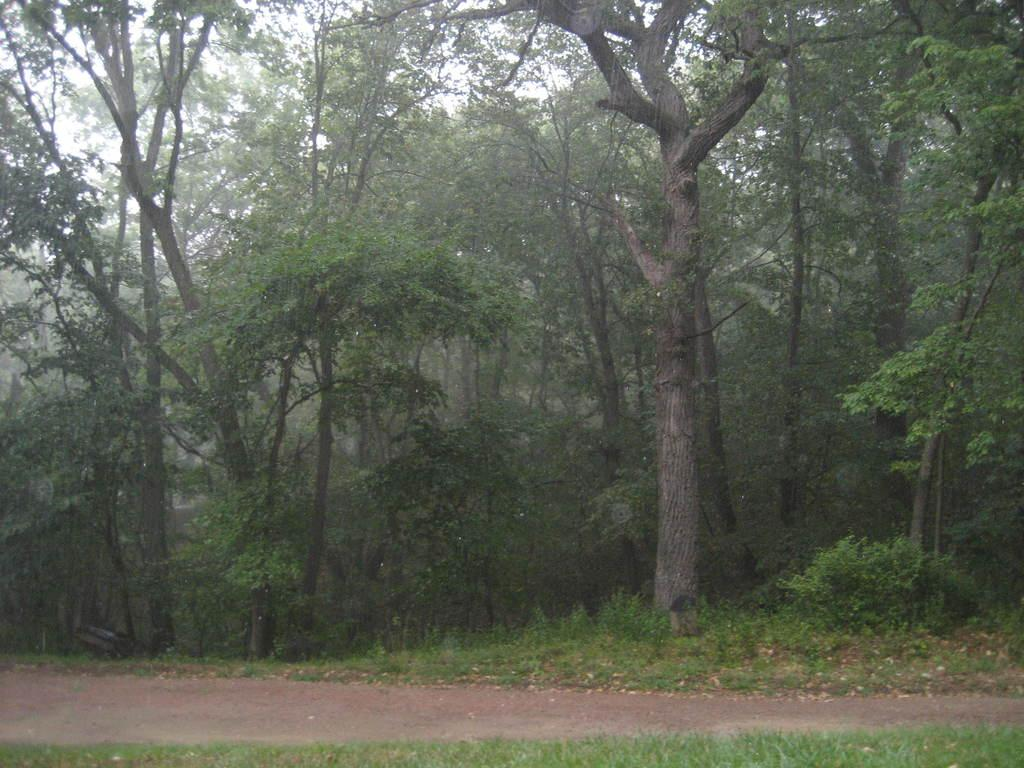What type of vegetation can be seen in the image? There are trees in the image. What is located at the bottom of the image? There is a path at the bottom of the image. What can be seen in the background of the image? The sky is visible in the background of the image. Where is the kitten sitting on the cushion in the image? There is no kitten or cushion present in the image. What type of screw is holding the tree in place in the image? There are no screws visible in the image, and trees are not held in place by screws. 